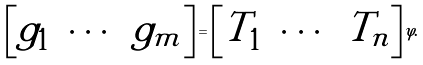Convert formula to latex. <formula><loc_0><loc_0><loc_500><loc_500>\begin{bmatrix} g _ { 1 } & \cdots & g _ { m } \end{bmatrix} = \begin{bmatrix} T _ { 1 } & \cdots & T _ { n } \end{bmatrix} \varphi .</formula> 